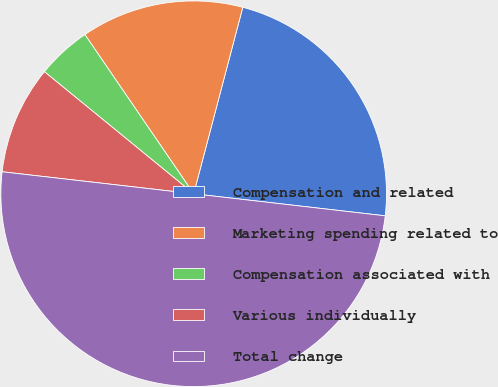Convert chart. <chart><loc_0><loc_0><loc_500><loc_500><pie_chart><fcel>Compensation and related<fcel>Marketing spending related to<fcel>Compensation associated with<fcel>Various individually<fcel>Total change<nl><fcel>22.73%<fcel>13.64%<fcel>4.55%<fcel>9.09%<fcel>50.0%<nl></chart> 